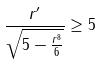Convert formula to latex. <formula><loc_0><loc_0><loc_500><loc_500>\frac { r ^ { \prime } } { \sqrt { 5 - \frac { r ^ { 8 } } { 6 } } } \geq 5</formula> 